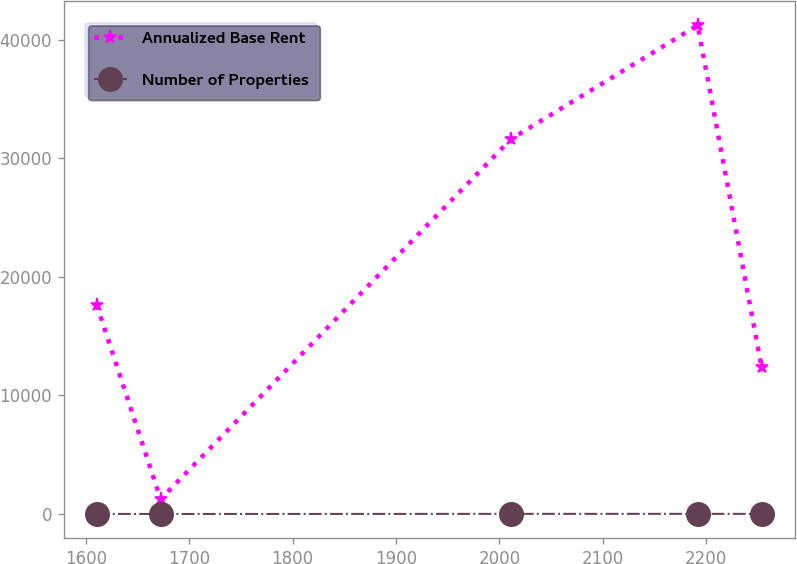Convert chart to OTSL. <chart><loc_0><loc_0><loc_500><loc_500><line_chart><ecel><fcel>Annualized Base Rent<fcel>Number of Properties<nl><fcel>1610.53<fcel>17623<fcel>11.09<nl><fcel>1672.27<fcel>1254.28<fcel>2.2<nl><fcel>2011.31<fcel>31640.1<fcel>13.33<nl><fcel>2191.87<fcel>41236.6<fcel>14.45<nl><fcel>2253.61<fcel>12439.9<fcel>12.21<nl></chart> 